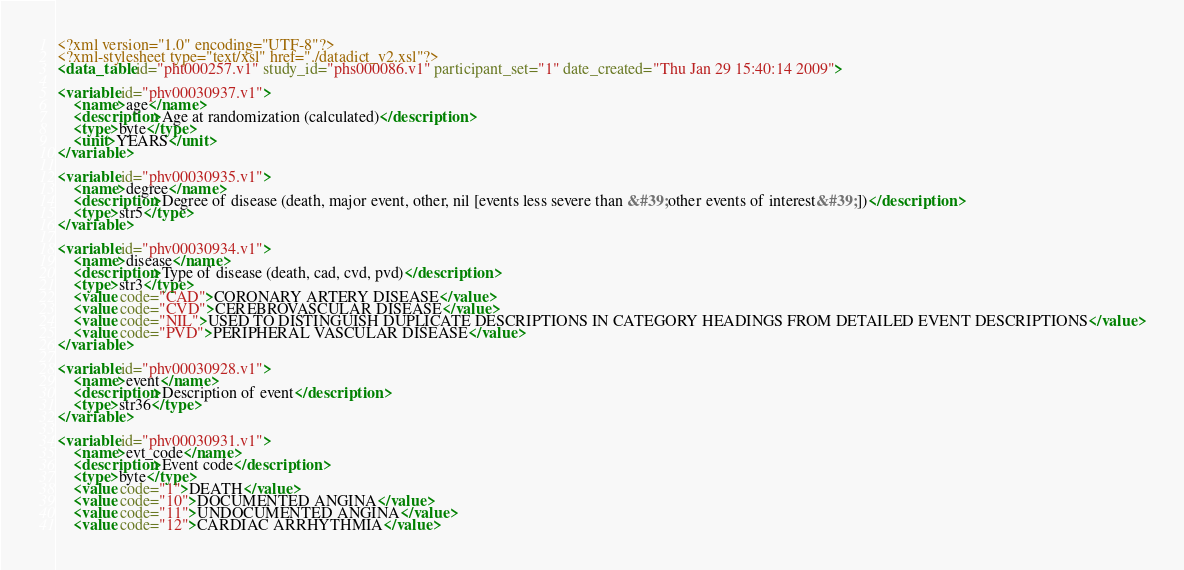<code> <loc_0><loc_0><loc_500><loc_500><_XML_><?xml version="1.0" encoding="UTF-8"?>
<?xml-stylesheet type="text/xsl" href="./datadict_v2.xsl"?>
<data_table id="pht000257.v1" study_id="phs000086.v1" participant_set="1" date_created="Thu Jan 29 15:40:14 2009">

<variable id="phv00030937.v1">
	<name>age</name>
	<description>Age at randomization (calculated)</description>
	<type>byte</type>
	<unit>YEARS</unit>
</variable>

<variable id="phv00030935.v1">
	<name>degree</name>
	<description>Degree of disease (death, major event, other, nil [events less severe than &#39;other events of interest&#39;])</description>
	<type>str5</type>
</variable>

<variable id="phv00030934.v1">
	<name>disease</name>
	<description>Type of disease (death, cad, cvd, pvd)</description>
	<type>str3</type>
	<value code="CAD">CORONARY ARTERY DISEASE</value>
	<value code="CVD">CEREBROVASCULAR DISEASE</value>
	<value code="NIL">USED TO DISTINGUISH DUPLICATE DESCRIPTIONS IN CATEGORY HEADINGS FROM DETAILED EVENT DESCRIPTIONS</value>
	<value code="PVD">PERIPHERAL VASCULAR DISEASE</value>
</variable>

<variable id="phv00030928.v1">
	<name>event</name>
	<description>Description of event</description>
	<type>str36</type>
</variable>

<variable id="phv00030931.v1">
	<name>evt_code</name>
	<description>Event code</description>
	<type>byte</type>
	<value code="1">DEATH</value>
	<value code="10">DOCUMENTED ANGINA</value>
	<value code="11">UNDOCUMENTED ANGINA</value>
	<value code="12">CARDIAC ARRHYTHMIA</value></code> 